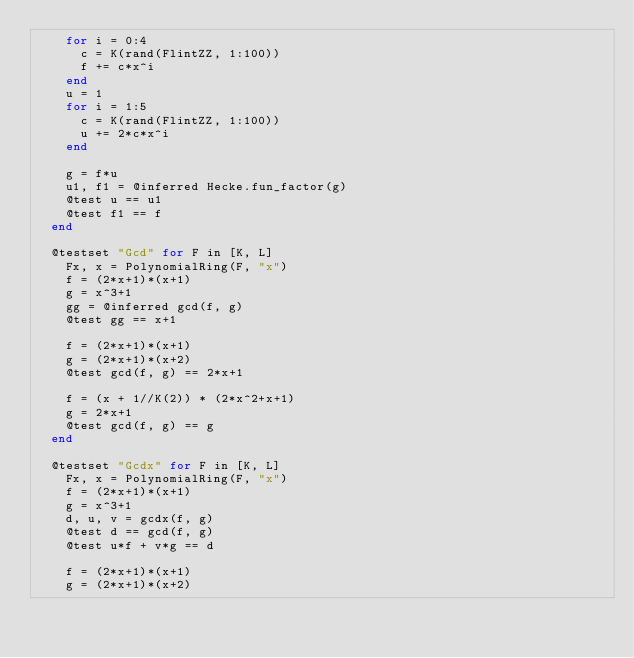Convert code to text. <code><loc_0><loc_0><loc_500><loc_500><_Julia_>    for i = 0:4
      c = K(rand(FlintZZ, 1:100))
      f += c*x^i
    end
    u = 1
    for i = 1:5
      c = K(rand(FlintZZ, 1:100))
      u += 2*c*x^i
    end

    g = f*u
    u1, f1 = @inferred Hecke.fun_factor(g)
    @test u == u1
    @test f1 == f
  end

  @testset "Gcd" for F in [K, L]
    Fx, x = PolynomialRing(F, "x")
    f = (2*x+1)*(x+1)
    g = x^3+1
    gg = @inferred gcd(f, g)
    @test gg == x+1

    f = (2*x+1)*(x+1)
    g = (2*x+1)*(x+2)
    @test gcd(f, g) == 2*x+1

    f = (x + 1//K(2)) * (2*x^2+x+1)
    g = 2*x+1
    @test gcd(f, g) == g
  end

  @testset "Gcdx" for F in [K, L]
    Fx, x = PolynomialRing(F, "x")
    f = (2*x+1)*(x+1)
    g = x^3+1
    d, u, v = gcdx(f, g)
    @test d == gcd(f, g)
    @test u*f + v*g == d

    f = (2*x+1)*(x+1)
    g = (2*x+1)*(x+2)</code> 